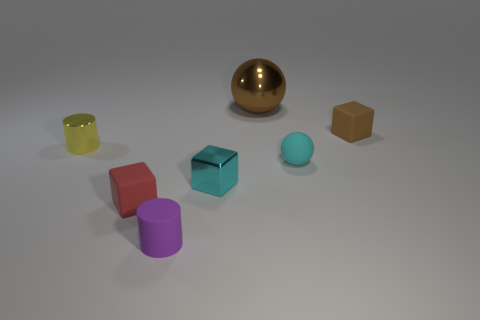Is there anything else that is the same size as the brown sphere?
Keep it short and to the point. No. What number of tiny cyan metallic things are there?
Ensure brevity in your answer.  1. Are there any brown objects made of the same material as the small ball?
Keep it short and to the point. Yes. The block that is the same color as the large metal thing is what size?
Make the answer very short. Small. There is a cylinder that is to the right of the tiny yellow metallic thing; is its size the same as the cylinder on the left side of the tiny purple thing?
Offer a terse response. Yes. How big is the matte cube to the right of the red matte block?
Provide a succinct answer. Small. Is there a tiny metallic thing that has the same color as the large shiny thing?
Provide a short and direct response. No. There is a metal thing on the right side of the cyan metal object; is there a small ball behind it?
Provide a succinct answer. No. There is a cyan matte ball; is it the same size as the cylinder that is behind the small purple rubber object?
Your answer should be very brief. Yes. There is a small cylinder right of the matte cube that is on the left side of the tiny matte cylinder; is there a cylinder in front of it?
Offer a very short reply. No. 